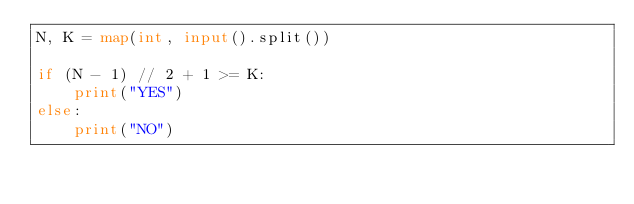Convert code to text. <code><loc_0><loc_0><loc_500><loc_500><_Python_>N, K = map(int, input().split())

if (N - 1) // 2 + 1 >= K:
    print("YES")
else:
    print("NO")</code> 